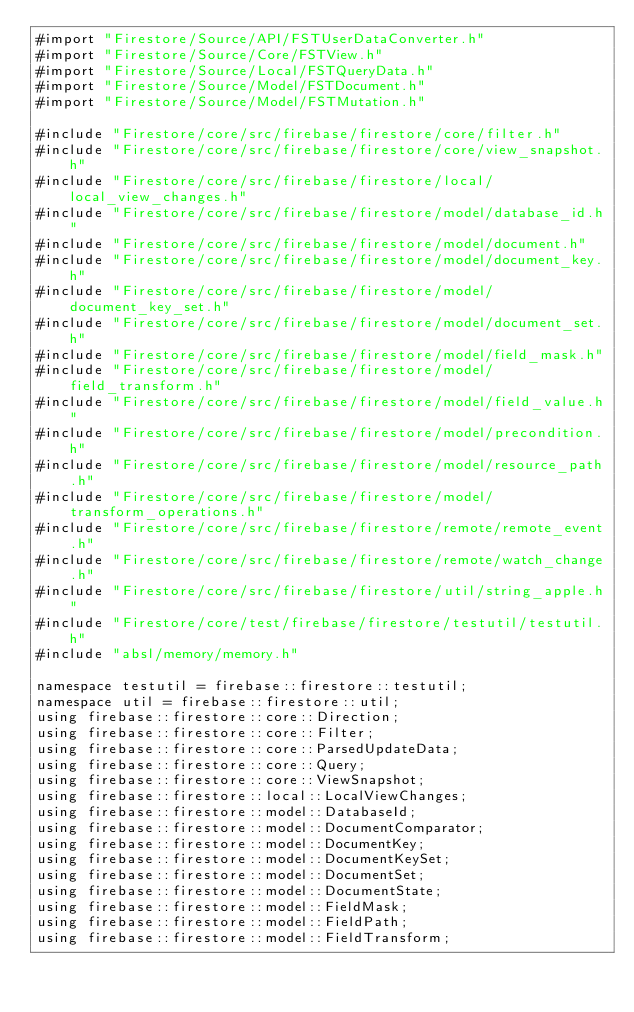Convert code to text. <code><loc_0><loc_0><loc_500><loc_500><_ObjectiveC_>#import "Firestore/Source/API/FSTUserDataConverter.h"
#import "Firestore/Source/Core/FSTView.h"
#import "Firestore/Source/Local/FSTQueryData.h"
#import "Firestore/Source/Model/FSTDocument.h"
#import "Firestore/Source/Model/FSTMutation.h"

#include "Firestore/core/src/firebase/firestore/core/filter.h"
#include "Firestore/core/src/firebase/firestore/core/view_snapshot.h"
#include "Firestore/core/src/firebase/firestore/local/local_view_changes.h"
#include "Firestore/core/src/firebase/firestore/model/database_id.h"
#include "Firestore/core/src/firebase/firestore/model/document.h"
#include "Firestore/core/src/firebase/firestore/model/document_key.h"
#include "Firestore/core/src/firebase/firestore/model/document_key_set.h"
#include "Firestore/core/src/firebase/firestore/model/document_set.h"
#include "Firestore/core/src/firebase/firestore/model/field_mask.h"
#include "Firestore/core/src/firebase/firestore/model/field_transform.h"
#include "Firestore/core/src/firebase/firestore/model/field_value.h"
#include "Firestore/core/src/firebase/firestore/model/precondition.h"
#include "Firestore/core/src/firebase/firestore/model/resource_path.h"
#include "Firestore/core/src/firebase/firestore/model/transform_operations.h"
#include "Firestore/core/src/firebase/firestore/remote/remote_event.h"
#include "Firestore/core/src/firebase/firestore/remote/watch_change.h"
#include "Firestore/core/src/firebase/firestore/util/string_apple.h"
#include "Firestore/core/test/firebase/firestore/testutil/testutil.h"
#include "absl/memory/memory.h"

namespace testutil = firebase::firestore::testutil;
namespace util = firebase::firestore::util;
using firebase::firestore::core::Direction;
using firebase::firestore::core::Filter;
using firebase::firestore::core::ParsedUpdateData;
using firebase::firestore::core::Query;
using firebase::firestore::core::ViewSnapshot;
using firebase::firestore::local::LocalViewChanges;
using firebase::firestore::model::DatabaseId;
using firebase::firestore::model::DocumentComparator;
using firebase::firestore::model::DocumentKey;
using firebase::firestore::model::DocumentKeySet;
using firebase::firestore::model::DocumentSet;
using firebase::firestore::model::DocumentState;
using firebase::firestore::model::FieldMask;
using firebase::firestore::model::FieldPath;
using firebase::firestore::model::FieldTransform;</code> 